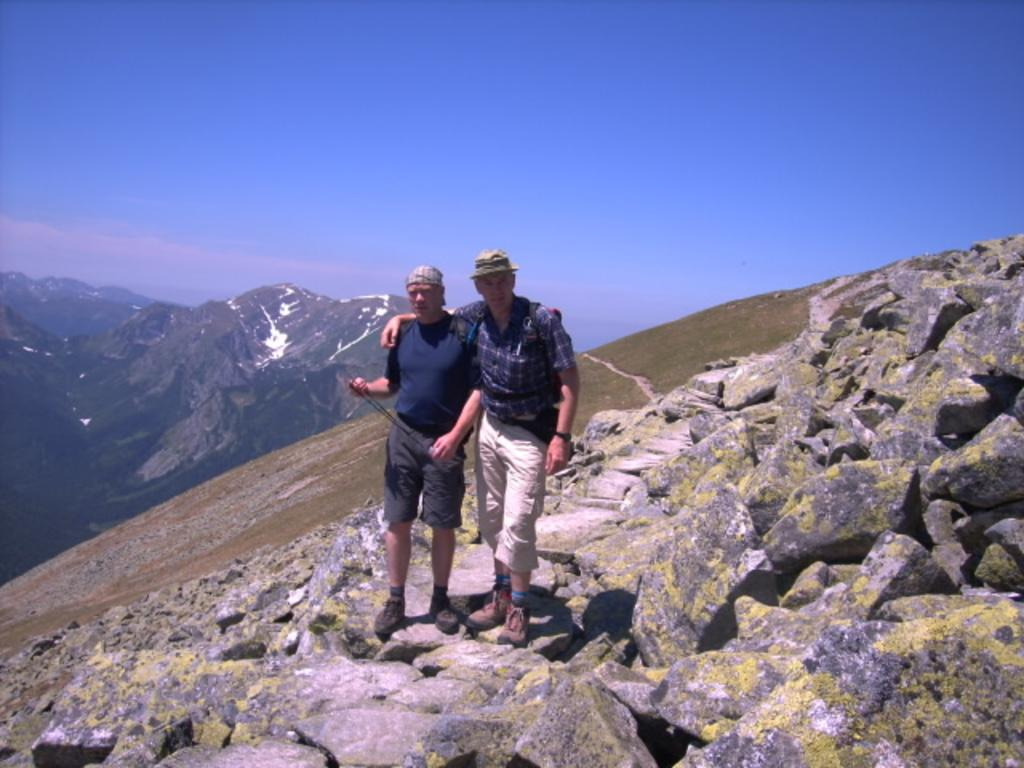How many people are in the image? There are two persons in the image. What are the persons standing on? The persons are standing on rocks. What can be seen in the background of the image? There are mountains and the sky visible in the background of the image. How does the digestion process affect the range of the persons in the image? There is no information about the digestion process or its effects on the persons in the image. The image only shows two people standing on rocks with mountains and the sky in the background. 